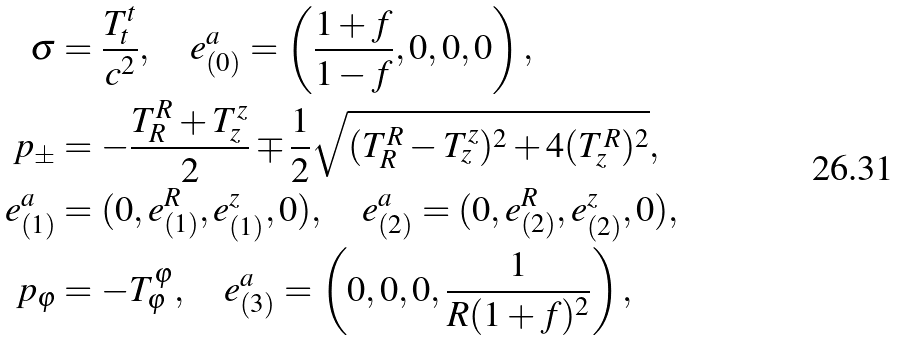<formula> <loc_0><loc_0><loc_500><loc_500>\sigma & = \frac { T ^ { t } _ { t } } { c ^ { 2 } } , \quad e _ { ( 0 ) } ^ { a } = \left ( \frac { 1 + f } { 1 - f } , 0 , 0 , 0 \right ) , \\ p _ { \pm } & = - \frac { T ^ { R } _ { R } + T ^ { z } _ { z } } { 2 } \mp \frac { 1 } { 2 } \sqrt { ( T ^ { R } _ { R } - T ^ { z } _ { z } ) ^ { 2 } + 4 ( T ^ { R } _ { z } ) ^ { 2 } } , \\ e _ { ( 1 ) } ^ { a } & = ( 0 , e _ { ( 1 ) } ^ { R } , e _ { ( 1 ) } ^ { z } , 0 ) , \quad e _ { ( 2 ) } ^ { a } = ( 0 , e _ { ( 2 ) } ^ { R } , e _ { ( 2 ) } ^ { z } , 0 ) , \\ p _ { \varphi } & = - T ^ { \varphi } _ { \varphi } , \quad e _ { ( 3 ) } ^ { a } = \left ( 0 , 0 , 0 , \frac { 1 } { R ( 1 + f ) ^ { 2 } } \right ) ,</formula> 